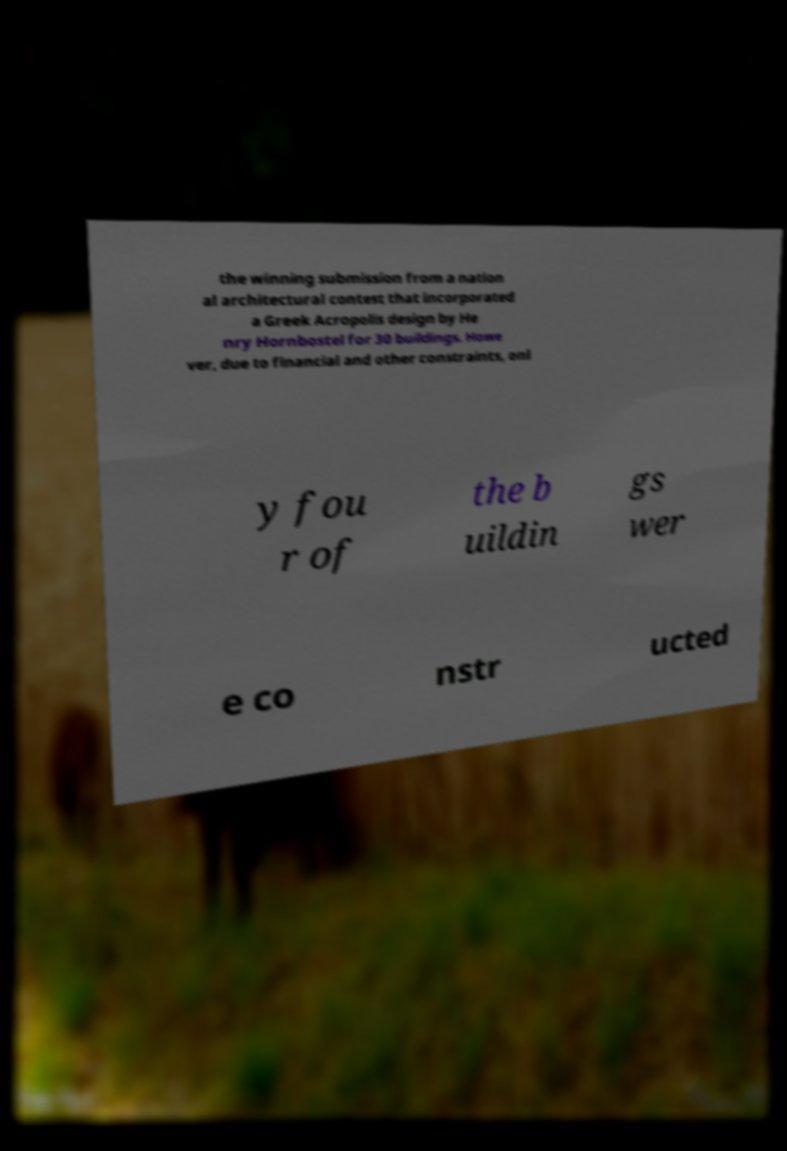Can you accurately transcribe the text from the provided image for me? the winning submission from a nation al architectural contest that incorporated a Greek Acropolis design by He nry Hornbostel for 30 buildings. Howe ver, due to financial and other constraints, onl y fou r of the b uildin gs wer e co nstr ucted 